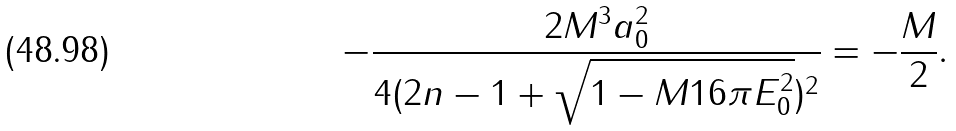<formula> <loc_0><loc_0><loc_500><loc_500>- \frac { 2 M ^ { 3 } a _ { 0 } ^ { 2 } } { 4 ( 2 n - 1 + \sqrt { 1 - M 1 6 \pi E _ { 0 } ^ { 2 } } ) ^ { 2 } } = - \frac { M } { 2 } .</formula> 